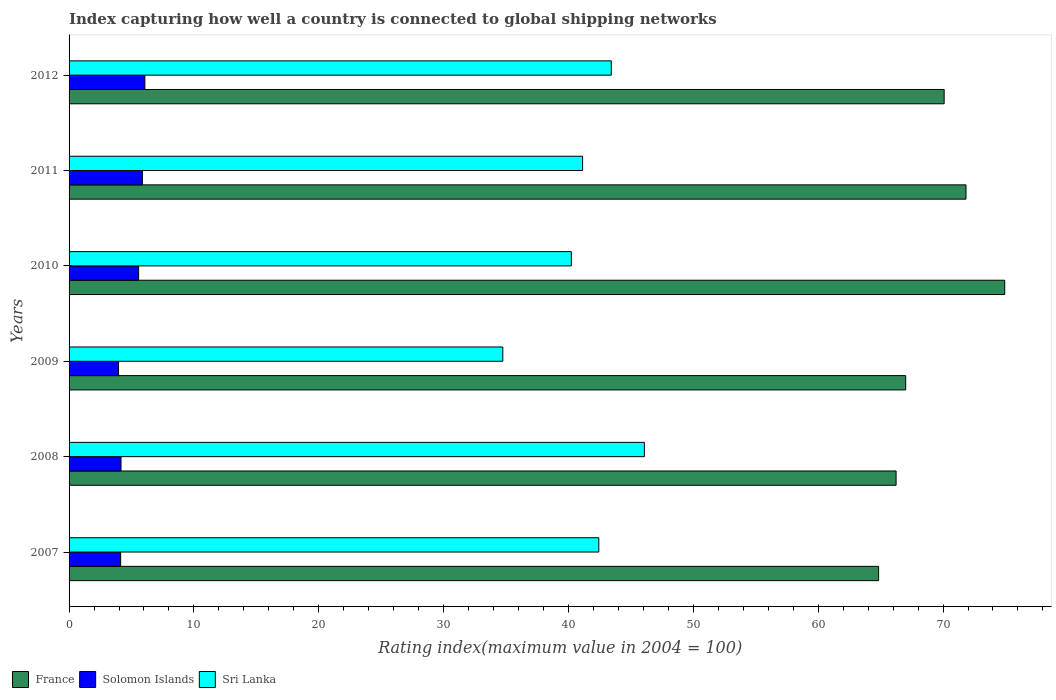Are the number of bars on each tick of the Y-axis equal?
Offer a terse response. Yes. How many bars are there on the 6th tick from the top?
Offer a terse response. 3. In how many cases, is the number of bars for a given year not equal to the number of legend labels?
Make the answer very short. 0. What is the rating index in Solomon Islands in 2008?
Give a very brief answer. 4.16. Across all years, what is the maximum rating index in Sri Lanka?
Ensure brevity in your answer.  46.08. Across all years, what is the minimum rating index in Solomon Islands?
Your answer should be very brief. 3.96. What is the total rating index in France in the graph?
Keep it short and to the point. 414.96. What is the difference between the rating index in Solomon Islands in 2008 and that in 2012?
Make the answer very short. -1.91. What is the difference between the rating index in Solomon Islands in 2011 and the rating index in France in 2007?
Provide a succinct answer. -58.97. What is the average rating index in Solomon Islands per year?
Make the answer very short. 4.96. In the year 2007, what is the difference between the rating index in Solomon Islands and rating index in Sri Lanka?
Keep it short and to the point. -38.3. In how many years, is the rating index in France greater than 8 ?
Offer a very short reply. 6. What is the ratio of the rating index in Sri Lanka in 2008 to that in 2011?
Provide a succinct answer. 1.12. What is the difference between the highest and the second highest rating index in Sri Lanka?
Your answer should be compact. 2.65. What is the difference between the highest and the lowest rating index in Solomon Islands?
Offer a very short reply. 2.11. Is the sum of the rating index in France in 2008 and 2011 greater than the maximum rating index in Solomon Islands across all years?
Offer a very short reply. Yes. What does the 2nd bar from the top in 2011 represents?
Keep it short and to the point. Solomon Islands. What does the 2nd bar from the bottom in 2008 represents?
Offer a very short reply. Solomon Islands. Is it the case that in every year, the sum of the rating index in Solomon Islands and rating index in France is greater than the rating index in Sri Lanka?
Offer a very short reply. Yes. Are all the bars in the graph horizontal?
Offer a terse response. Yes. How many years are there in the graph?
Offer a terse response. 6. What is the difference between two consecutive major ticks on the X-axis?
Your answer should be very brief. 10. Are the values on the major ticks of X-axis written in scientific E-notation?
Make the answer very short. No. Does the graph contain grids?
Offer a very short reply. No. Where does the legend appear in the graph?
Your response must be concise. Bottom left. How many legend labels are there?
Keep it short and to the point. 3. What is the title of the graph?
Provide a succinct answer. Index capturing how well a country is connected to global shipping networks. What is the label or title of the X-axis?
Make the answer very short. Rating index(maximum value in 2004 = 100). What is the label or title of the Y-axis?
Provide a short and direct response. Years. What is the Rating index(maximum value in 2004 = 100) in France in 2007?
Your response must be concise. 64.84. What is the Rating index(maximum value in 2004 = 100) of Solomon Islands in 2007?
Your answer should be compact. 4.13. What is the Rating index(maximum value in 2004 = 100) of Sri Lanka in 2007?
Ensure brevity in your answer.  42.43. What is the Rating index(maximum value in 2004 = 100) of France in 2008?
Your answer should be compact. 66.24. What is the Rating index(maximum value in 2004 = 100) of Solomon Islands in 2008?
Your answer should be compact. 4.16. What is the Rating index(maximum value in 2004 = 100) of Sri Lanka in 2008?
Make the answer very short. 46.08. What is the Rating index(maximum value in 2004 = 100) in France in 2009?
Your answer should be compact. 67.01. What is the Rating index(maximum value in 2004 = 100) in Solomon Islands in 2009?
Offer a terse response. 3.96. What is the Rating index(maximum value in 2004 = 100) of Sri Lanka in 2009?
Your response must be concise. 34.74. What is the Rating index(maximum value in 2004 = 100) in France in 2010?
Give a very brief answer. 74.94. What is the Rating index(maximum value in 2004 = 100) in Solomon Islands in 2010?
Provide a succinct answer. 5.57. What is the Rating index(maximum value in 2004 = 100) in Sri Lanka in 2010?
Provide a succinct answer. 40.23. What is the Rating index(maximum value in 2004 = 100) of France in 2011?
Your answer should be very brief. 71.84. What is the Rating index(maximum value in 2004 = 100) in Solomon Islands in 2011?
Keep it short and to the point. 5.87. What is the Rating index(maximum value in 2004 = 100) of Sri Lanka in 2011?
Keep it short and to the point. 41.13. What is the Rating index(maximum value in 2004 = 100) in France in 2012?
Offer a very short reply. 70.09. What is the Rating index(maximum value in 2004 = 100) of Solomon Islands in 2012?
Make the answer very short. 6.07. What is the Rating index(maximum value in 2004 = 100) of Sri Lanka in 2012?
Give a very brief answer. 43.43. Across all years, what is the maximum Rating index(maximum value in 2004 = 100) of France?
Give a very brief answer. 74.94. Across all years, what is the maximum Rating index(maximum value in 2004 = 100) of Solomon Islands?
Your answer should be very brief. 6.07. Across all years, what is the maximum Rating index(maximum value in 2004 = 100) of Sri Lanka?
Offer a very short reply. 46.08. Across all years, what is the minimum Rating index(maximum value in 2004 = 100) of France?
Offer a very short reply. 64.84. Across all years, what is the minimum Rating index(maximum value in 2004 = 100) in Solomon Islands?
Offer a very short reply. 3.96. Across all years, what is the minimum Rating index(maximum value in 2004 = 100) of Sri Lanka?
Offer a terse response. 34.74. What is the total Rating index(maximum value in 2004 = 100) of France in the graph?
Offer a terse response. 414.96. What is the total Rating index(maximum value in 2004 = 100) in Solomon Islands in the graph?
Offer a terse response. 29.76. What is the total Rating index(maximum value in 2004 = 100) of Sri Lanka in the graph?
Give a very brief answer. 248.04. What is the difference between the Rating index(maximum value in 2004 = 100) of France in 2007 and that in 2008?
Offer a very short reply. -1.4. What is the difference between the Rating index(maximum value in 2004 = 100) of Solomon Islands in 2007 and that in 2008?
Provide a succinct answer. -0.03. What is the difference between the Rating index(maximum value in 2004 = 100) of Sri Lanka in 2007 and that in 2008?
Your response must be concise. -3.65. What is the difference between the Rating index(maximum value in 2004 = 100) of France in 2007 and that in 2009?
Provide a succinct answer. -2.17. What is the difference between the Rating index(maximum value in 2004 = 100) in Solomon Islands in 2007 and that in 2009?
Provide a short and direct response. 0.17. What is the difference between the Rating index(maximum value in 2004 = 100) in Sri Lanka in 2007 and that in 2009?
Your answer should be compact. 7.69. What is the difference between the Rating index(maximum value in 2004 = 100) in Solomon Islands in 2007 and that in 2010?
Provide a short and direct response. -1.44. What is the difference between the Rating index(maximum value in 2004 = 100) in Sri Lanka in 2007 and that in 2010?
Provide a succinct answer. 2.2. What is the difference between the Rating index(maximum value in 2004 = 100) of France in 2007 and that in 2011?
Make the answer very short. -7. What is the difference between the Rating index(maximum value in 2004 = 100) in Solomon Islands in 2007 and that in 2011?
Provide a succinct answer. -1.74. What is the difference between the Rating index(maximum value in 2004 = 100) in France in 2007 and that in 2012?
Provide a succinct answer. -5.25. What is the difference between the Rating index(maximum value in 2004 = 100) in Solomon Islands in 2007 and that in 2012?
Give a very brief answer. -1.94. What is the difference between the Rating index(maximum value in 2004 = 100) in France in 2008 and that in 2009?
Provide a succinct answer. -0.77. What is the difference between the Rating index(maximum value in 2004 = 100) in Solomon Islands in 2008 and that in 2009?
Make the answer very short. 0.2. What is the difference between the Rating index(maximum value in 2004 = 100) in Sri Lanka in 2008 and that in 2009?
Give a very brief answer. 11.34. What is the difference between the Rating index(maximum value in 2004 = 100) in Solomon Islands in 2008 and that in 2010?
Provide a short and direct response. -1.41. What is the difference between the Rating index(maximum value in 2004 = 100) of Sri Lanka in 2008 and that in 2010?
Provide a succinct answer. 5.85. What is the difference between the Rating index(maximum value in 2004 = 100) in France in 2008 and that in 2011?
Your answer should be compact. -5.6. What is the difference between the Rating index(maximum value in 2004 = 100) in Solomon Islands in 2008 and that in 2011?
Make the answer very short. -1.71. What is the difference between the Rating index(maximum value in 2004 = 100) in Sri Lanka in 2008 and that in 2011?
Provide a succinct answer. 4.95. What is the difference between the Rating index(maximum value in 2004 = 100) of France in 2008 and that in 2012?
Keep it short and to the point. -3.85. What is the difference between the Rating index(maximum value in 2004 = 100) in Solomon Islands in 2008 and that in 2012?
Ensure brevity in your answer.  -1.91. What is the difference between the Rating index(maximum value in 2004 = 100) in Sri Lanka in 2008 and that in 2012?
Ensure brevity in your answer.  2.65. What is the difference between the Rating index(maximum value in 2004 = 100) in France in 2009 and that in 2010?
Provide a short and direct response. -7.93. What is the difference between the Rating index(maximum value in 2004 = 100) of Solomon Islands in 2009 and that in 2010?
Keep it short and to the point. -1.61. What is the difference between the Rating index(maximum value in 2004 = 100) in Sri Lanka in 2009 and that in 2010?
Offer a very short reply. -5.49. What is the difference between the Rating index(maximum value in 2004 = 100) in France in 2009 and that in 2011?
Offer a terse response. -4.83. What is the difference between the Rating index(maximum value in 2004 = 100) in Solomon Islands in 2009 and that in 2011?
Make the answer very short. -1.91. What is the difference between the Rating index(maximum value in 2004 = 100) in Sri Lanka in 2009 and that in 2011?
Your answer should be compact. -6.39. What is the difference between the Rating index(maximum value in 2004 = 100) in France in 2009 and that in 2012?
Provide a succinct answer. -3.08. What is the difference between the Rating index(maximum value in 2004 = 100) in Solomon Islands in 2009 and that in 2012?
Your answer should be compact. -2.11. What is the difference between the Rating index(maximum value in 2004 = 100) in Sri Lanka in 2009 and that in 2012?
Offer a terse response. -8.69. What is the difference between the Rating index(maximum value in 2004 = 100) of Solomon Islands in 2010 and that in 2011?
Offer a very short reply. -0.3. What is the difference between the Rating index(maximum value in 2004 = 100) of France in 2010 and that in 2012?
Your response must be concise. 4.85. What is the difference between the Rating index(maximum value in 2004 = 100) of France in 2011 and that in 2012?
Provide a succinct answer. 1.75. What is the difference between the Rating index(maximum value in 2004 = 100) in Solomon Islands in 2011 and that in 2012?
Provide a short and direct response. -0.2. What is the difference between the Rating index(maximum value in 2004 = 100) of France in 2007 and the Rating index(maximum value in 2004 = 100) of Solomon Islands in 2008?
Your answer should be compact. 60.68. What is the difference between the Rating index(maximum value in 2004 = 100) of France in 2007 and the Rating index(maximum value in 2004 = 100) of Sri Lanka in 2008?
Keep it short and to the point. 18.76. What is the difference between the Rating index(maximum value in 2004 = 100) in Solomon Islands in 2007 and the Rating index(maximum value in 2004 = 100) in Sri Lanka in 2008?
Your answer should be very brief. -41.95. What is the difference between the Rating index(maximum value in 2004 = 100) of France in 2007 and the Rating index(maximum value in 2004 = 100) of Solomon Islands in 2009?
Your answer should be very brief. 60.88. What is the difference between the Rating index(maximum value in 2004 = 100) of France in 2007 and the Rating index(maximum value in 2004 = 100) of Sri Lanka in 2009?
Your response must be concise. 30.1. What is the difference between the Rating index(maximum value in 2004 = 100) in Solomon Islands in 2007 and the Rating index(maximum value in 2004 = 100) in Sri Lanka in 2009?
Provide a short and direct response. -30.61. What is the difference between the Rating index(maximum value in 2004 = 100) of France in 2007 and the Rating index(maximum value in 2004 = 100) of Solomon Islands in 2010?
Provide a short and direct response. 59.27. What is the difference between the Rating index(maximum value in 2004 = 100) in France in 2007 and the Rating index(maximum value in 2004 = 100) in Sri Lanka in 2010?
Your response must be concise. 24.61. What is the difference between the Rating index(maximum value in 2004 = 100) in Solomon Islands in 2007 and the Rating index(maximum value in 2004 = 100) in Sri Lanka in 2010?
Give a very brief answer. -36.1. What is the difference between the Rating index(maximum value in 2004 = 100) in France in 2007 and the Rating index(maximum value in 2004 = 100) in Solomon Islands in 2011?
Give a very brief answer. 58.97. What is the difference between the Rating index(maximum value in 2004 = 100) in France in 2007 and the Rating index(maximum value in 2004 = 100) in Sri Lanka in 2011?
Your response must be concise. 23.71. What is the difference between the Rating index(maximum value in 2004 = 100) of Solomon Islands in 2007 and the Rating index(maximum value in 2004 = 100) of Sri Lanka in 2011?
Ensure brevity in your answer.  -37. What is the difference between the Rating index(maximum value in 2004 = 100) of France in 2007 and the Rating index(maximum value in 2004 = 100) of Solomon Islands in 2012?
Offer a very short reply. 58.77. What is the difference between the Rating index(maximum value in 2004 = 100) of France in 2007 and the Rating index(maximum value in 2004 = 100) of Sri Lanka in 2012?
Your answer should be compact. 21.41. What is the difference between the Rating index(maximum value in 2004 = 100) of Solomon Islands in 2007 and the Rating index(maximum value in 2004 = 100) of Sri Lanka in 2012?
Provide a succinct answer. -39.3. What is the difference between the Rating index(maximum value in 2004 = 100) in France in 2008 and the Rating index(maximum value in 2004 = 100) in Solomon Islands in 2009?
Ensure brevity in your answer.  62.28. What is the difference between the Rating index(maximum value in 2004 = 100) of France in 2008 and the Rating index(maximum value in 2004 = 100) of Sri Lanka in 2009?
Ensure brevity in your answer.  31.5. What is the difference between the Rating index(maximum value in 2004 = 100) of Solomon Islands in 2008 and the Rating index(maximum value in 2004 = 100) of Sri Lanka in 2009?
Your response must be concise. -30.58. What is the difference between the Rating index(maximum value in 2004 = 100) in France in 2008 and the Rating index(maximum value in 2004 = 100) in Solomon Islands in 2010?
Keep it short and to the point. 60.67. What is the difference between the Rating index(maximum value in 2004 = 100) in France in 2008 and the Rating index(maximum value in 2004 = 100) in Sri Lanka in 2010?
Provide a succinct answer. 26.01. What is the difference between the Rating index(maximum value in 2004 = 100) in Solomon Islands in 2008 and the Rating index(maximum value in 2004 = 100) in Sri Lanka in 2010?
Provide a short and direct response. -36.07. What is the difference between the Rating index(maximum value in 2004 = 100) in France in 2008 and the Rating index(maximum value in 2004 = 100) in Solomon Islands in 2011?
Provide a succinct answer. 60.37. What is the difference between the Rating index(maximum value in 2004 = 100) in France in 2008 and the Rating index(maximum value in 2004 = 100) in Sri Lanka in 2011?
Offer a very short reply. 25.11. What is the difference between the Rating index(maximum value in 2004 = 100) of Solomon Islands in 2008 and the Rating index(maximum value in 2004 = 100) of Sri Lanka in 2011?
Provide a short and direct response. -36.97. What is the difference between the Rating index(maximum value in 2004 = 100) in France in 2008 and the Rating index(maximum value in 2004 = 100) in Solomon Islands in 2012?
Your answer should be very brief. 60.17. What is the difference between the Rating index(maximum value in 2004 = 100) of France in 2008 and the Rating index(maximum value in 2004 = 100) of Sri Lanka in 2012?
Keep it short and to the point. 22.81. What is the difference between the Rating index(maximum value in 2004 = 100) of Solomon Islands in 2008 and the Rating index(maximum value in 2004 = 100) of Sri Lanka in 2012?
Ensure brevity in your answer.  -39.27. What is the difference between the Rating index(maximum value in 2004 = 100) of France in 2009 and the Rating index(maximum value in 2004 = 100) of Solomon Islands in 2010?
Provide a succinct answer. 61.44. What is the difference between the Rating index(maximum value in 2004 = 100) in France in 2009 and the Rating index(maximum value in 2004 = 100) in Sri Lanka in 2010?
Your answer should be very brief. 26.78. What is the difference between the Rating index(maximum value in 2004 = 100) of Solomon Islands in 2009 and the Rating index(maximum value in 2004 = 100) of Sri Lanka in 2010?
Provide a succinct answer. -36.27. What is the difference between the Rating index(maximum value in 2004 = 100) of France in 2009 and the Rating index(maximum value in 2004 = 100) of Solomon Islands in 2011?
Your answer should be compact. 61.14. What is the difference between the Rating index(maximum value in 2004 = 100) in France in 2009 and the Rating index(maximum value in 2004 = 100) in Sri Lanka in 2011?
Make the answer very short. 25.88. What is the difference between the Rating index(maximum value in 2004 = 100) in Solomon Islands in 2009 and the Rating index(maximum value in 2004 = 100) in Sri Lanka in 2011?
Your response must be concise. -37.17. What is the difference between the Rating index(maximum value in 2004 = 100) in France in 2009 and the Rating index(maximum value in 2004 = 100) in Solomon Islands in 2012?
Offer a very short reply. 60.94. What is the difference between the Rating index(maximum value in 2004 = 100) of France in 2009 and the Rating index(maximum value in 2004 = 100) of Sri Lanka in 2012?
Offer a very short reply. 23.58. What is the difference between the Rating index(maximum value in 2004 = 100) of Solomon Islands in 2009 and the Rating index(maximum value in 2004 = 100) of Sri Lanka in 2012?
Give a very brief answer. -39.47. What is the difference between the Rating index(maximum value in 2004 = 100) in France in 2010 and the Rating index(maximum value in 2004 = 100) in Solomon Islands in 2011?
Make the answer very short. 69.07. What is the difference between the Rating index(maximum value in 2004 = 100) of France in 2010 and the Rating index(maximum value in 2004 = 100) of Sri Lanka in 2011?
Your response must be concise. 33.81. What is the difference between the Rating index(maximum value in 2004 = 100) in Solomon Islands in 2010 and the Rating index(maximum value in 2004 = 100) in Sri Lanka in 2011?
Make the answer very short. -35.56. What is the difference between the Rating index(maximum value in 2004 = 100) in France in 2010 and the Rating index(maximum value in 2004 = 100) in Solomon Islands in 2012?
Your answer should be very brief. 68.87. What is the difference between the Rating index(maximum value in 2004 = 100) in France in 2010 and the Rating index(maximum value in 2004 = 100) in Sri Lanka in 2012?
Your answer should be very brief. 31.51. What is the difference between the Rating index(maximum value in 2004 = 100) of Solomon Islands in 2010 and the Rating index(maximum value in 2004 = 100) of Sri Lanka in 2012?
Give a very brief answer. -37.86. What is the difference between the Rating index(maximum value in 2004 = 100) in France in 2011 and the Rating index(maximum value in 2004 = 100) in Solomon Islands in 2012?
Your response must be concise. 65.77. What is the difference between the Rating index(maximum value in 2004 = 100) in France in 2011 and the Rating index(maximum value in 2004 = 100) in Sri Lanka in 2012?
Offer a terse response. 28.41. What is the difference between the Rating index(maximum value in 2004 = 100) of Solomon Islands in 2011 and the Rating index(maximum value in 2004 = 100) of Sri Lanka in 2012?
Offer a terse response. -37.56. What is the average Rating index(maximum value in 2004 = 100) of France per year?
Offer a very short reply. 69.16. What is the average Rating index(maximum value in 2004 = 100) of Solomon Islands per year?
Offer a very short reply. 4.96. What is the average Rating index(maximum value in 2004 = 100) of Sri Lanka per year?
Keep it short and to the point. 41.34. In the year 2007, what is the difference between the Rating index(maximum value in 2004 = 100) in France and Rating index(maximum value in 2004 = 100) in Solomon Islands?
Give a very brief answer. 60.71. In the year 2007, what is the difference between the Rating index(maximum value in 2004 = 100) of France and Rating index(maximum value in 2004 = 100) of Sri Lanka?
Provide a short and direct response. 22.41. In the year 2007, what is the difference between the Rating index(maximum value in 2004 = 100) of Solomon Islands and Rating index(maximum value in 2004 = 100) of Sri Lanka?
Ensure brevity in your answer.  -38.3. In the year 2008, what is the difference between the Rating index(maximum value in 2004 = 100) in France and Rating index(maximum value in 2004 = 100) in Solomon Islands?
Offer a very short reply. 62.08. In the year 2008, what is the difference between the Rating index(maximum value in 2004 = 100) in France and Rating index(maximum value in 2004 = 100) in Sri Lanka?
Keep it short and to the point. 20.16. In the year 2008, what is the difference between the Rating index(maximum value in 2004 = 100) of Solomon Islands and Rating index(maximum value in 2004 = 100) of Sri Lanka?
Keep it short and to the point. -41.92. In the year 2009, what is the difference between the Rating index(maximum value in 2004 = 100) in France and Rating index(maximum value in 2004 = 100) in Solomon Islands?
Provide a succinct answer. 63.05. In the year 2009, what is the difference between the Rating index(maximum value in 2004 = 100) of France and Rating index(maximum value in 2004 = 100) of Sri Lanka?
Provide a succinct answer. 32.27. In the year 2009, what is the difference between the Rating index(maximum value in 2004 = 100) of Solomon Islands and Rating index(maximum value in 2004 = 100) of Sri Lanka?
Ensure brevity in your answer.  -30.78. In the year 2010, what is the difference between the Rating index(maximum value in 2004 = 100) of France and Rating index(maximum value in 2004 = 100) of Solomon Islands?
Keep it short and to the point. 69.37. In the year 2010, what is the difference between the Rating index(maximum value in 2004 = 100) of France and Rating index(maximum value in 2004 = 100) of Sri Lanka?
Give a very brief answer. 34.71. In the year 2010, what is the difference between the Rating index(maximum value in 2004 = 100) in Solomon Islands and Rating index(maximum value in 2004 = 100) in Sri Lanka?
Offer a very short reply. -34.66. In the year 2011, what is the difference between the Rating index(maximum value in 2004 = 100) of France and Rating index(maximum value in 2004 = 100) of Solomon Islands?
Your answer should be very brief. 65.97. In the year 2011, what is the difference between the Rating index(maximum value in 2004 = 100) of France and Rating index(maximum value in 2004 = 100) of Sri Lanka?
Your answer should be very brief. 30.71. In the year 2011, what is the difference between the Rating index(maximum value in 2004 = 100) in Solomon Islands and Rating index(maximum value in 2004 = 100) in Sri Lanka?
Make the answer very short. -35.26. In the year 2012, what is the difference between the Rating index(maximum value in 2004 = 100) of France and Rating index(maximum value in 2004 = 100) of Solomon Islands?
Your response must be concise. 64.02. In the year 2012, what is the difference between the Rating index(maximum value in 2004 = 100) of France and Rating index(maximum value in 2004 = 100) of Sri Lanka?
Keep it short and to the point. 26.66. In the year 2012, what is the difference between the Rating index(maximum value in 2004 = 100) in Solomon Islands and Rating index(maximum value in 2004 = 100) in Sri Lanka?
Your response must be concise. -37.36. What is the ratio of the Rating index(maximum value in 2004 = 100) of France in 2007 to that in 2008?
Your answer should be compact. 0.98. What is the ratio of the Rating index(maximum value in 2004 = 100) of Solomon Islands in 2007 to that in 2008?
Your response must be concise. 0.99. What is the ratio of the Rating index(maximum value in 2004 = 100) of Sri Lanka in 2007 to that in 2008?
Ensure brevity in your answer.  0.92. What is the ratio of the Rating index(maximum value in 2004 = 100) of France in 2007 to that in 2009?
Provide a succinct answer. 0.97. What is the ratio of the Rating index(maximum value in 2004 = 100) in Solomon Islands in 2007 to that in 2009?
Your response must be concise. 1.04. What is the ratio of the Rating index(maximum value in 2004 = 100) in Sri Lanka in 2007 to that in 2009?
Keep it short and to the point. 1.22. What is the ratio of the Rating index(maximum value in 2004 = 100) of France in 2007 to that in 2010?
Offer a very short reply. 0.87. What is the ratio of the Rating index(maximum value in 2004 = 100) of Solomon Islands in 2007 to that in 2010?
Ensure brevity in your answer.  0.74. What is the ratio of the Rating index(maximum value in 2004 = 100) in Sri Lanka in 2007 to that in 2010?
Your answer should be compact. 1.05. What is the ratio of the Rating index(maximum value in 2004 = 100) in France in 2007 to that in 2011?
Give a very brief answer. 0.9. What is the ratio of the Rating index(maximum value in 2004 = 100) of Solomon Islands in 2007 to that in 2011?
Make the answer very short. 0.7. What is the ratio of the Rating index(maximum value in 2004 = 100) of Sri Lanka in 2007 to that in 2011?
Keep it short and to the point. 1.03. What is the ratio of the Rating index(maximum value in 2004 = 100) of France in 2007 to that in 2012?
Your response must be concise. 0.93. What is the ratio of the Rating index(maximum value in 2004 = 100) of Solomon Islands in 2007 to that in 2012?
Your response must be concise. 0.68. What is the ratio of the Rating index(maximum value in 2004 = 100) of Sri Lanka in 2007 to that in 2012?
Make the answer very short. 0.98. What is the ratio of the Rating index(maximum value in 2004 = 100) in Solomon Islands in 2008 to that in 2009?
Your answer should be compact. 1.05. What is the ratio of the Rating index(maximum value in 2004 = 100) in Sri Lanka in 2008 to that in 2009?
Provide a succinct answer. 1.33. What is the ratio of the Rating index(maximum value in 2004 = 100) of France in 2008 to that in 2010?
Your answer should be very brief. 0.88. What is the ratio of the Rating index(maximum value in 2004 = 100) in Solomon Islands in 2008 to that in 2010?
Make the answer very short. 0.75. What is the ratio of the Rating index(maximum value in 2004 = 100) of Sri Lanka in 2008 to that in 2010?
Your answer should be very brief. 1.15. What is the ratio of the Rating index(maximum value in 2004 = 100) of France in 2008 to that in 2011?
Your response must be concise. 0.92. What is the ratio of the Rating index(maximum value in 2004 = 100) in Solomon Islands in 2008 to that in 2011?
Make the answer very short. 0.71. What is the ratio of the Rating index(maximum value in 2004 = 100) of Sri Lanka in 2008 to that in 2011?
Offer a terse response. 1.12. What is the ratio of the Rating index(maximum value in 2004 = 100) of France in 2008 to that in 2012?
Provide a succinct answer. 0.95. What is the ratio of the Rating index(maximum value in 2004 = 100) of Solomon Islands in 2008 to that in 2012?
Make the answer very short. 0.69. What is the ratio of the Rating index(maximum value in 2004 = 100) of Sri Lanka in 2008 to that in 2012?
Offer a very short reply. 1.06. What is the ratio of the Rating index(maximum value in 2004 = 100) of France in 2009 to that in 2010?
Keep it short and to the point. 0.89. What is the ratio of the Rating index(maximum value in 2004 = 100) in Solomon Islands in 2009 to that in 2010?
Your answer should be very brief. 0.71. What is the ratio of the Rating index(maximum value in 2004 = 100) of Sri Lanka in 2009 to that in 2010?
Give a very brief answer. 0.86. What is the ratio of the Rating index(maximum value in 2004 = 100) of France in 2009 to that in 2011?
Give a very brief answer. 0.93. What is the ratio of the Rating index(maximum value in 2004 = 100) in Solomon Islands in 2009 to that in 2011?
Your answer should be very brief. 0.67. What is the ratio of the Rating index(maximum value in 2004 = 100) of Sri Lanka in 2009 to that in 2011?
Ensure brevity in your answer.  0.84. What is the ratio of the Rating index(maximum value in 2004 = 100) of France in 2009 to that in 2012?
Your answer should be very brief. 0.96. What is the ratio of the Rating index(maximum value in 2004 = 100) in Solomon Islands in 2009 to that in 2012?
Your answer should be compact. 0.65. What is the ratio of the Rating index(maximum value in 2004 = 100) in Sri Lanka in 2009 to that in 2012?
Provide a short and direct response. 0.8. What is the ratio of the Rating index(maximum value in 2004 = 100) in France in 2010 to that in 2011?
Ensure brevity in your answer.  1.04. What is the ratio of the Rating index(maximum value in 2004 = 100) in Solomon Islands in 2010 to that in 2011?
Your answer should be very brief. 0.95. What is the ratio of the Rating index(maximum value in 2004 = 100) of Sri Lanka in 2010 to that in 2011?
Give a very brief answer. 0.98. What is the ratio of the Rating index(maximum value in 2004 = 100) in France in 2010 to that in 2012?
Provide a succinct answer. 1.07. What is the ratio of the Rating index(maximum value in 2004 = 100) in Solomon Islands in 2010 to that in 2012?
Give a very brief answer. 0.92. What is the ratio of the Rating index(maximum value in 2004 = 100) of Sri Lanka in 2010 to that in 2012?
Your response must be concise. 0.93. What is the ratio of the Rating index(maximum value in 2004 = 100) of Solomon Islands in 2011 to that in 2012?
Offer a very short reply. 0.97. What is the ratio of the Rating index(maximum value in 2004 = 100) of Sri Lanka in 2011 to that in 2012?
Your answer should be compact. 0.95. What is the difference between the highest and the second highest Rating index(maximum value in 2004 = 100) in France?
Provide a succinct answer. 3.1. What is the difference between the highest and the second highest Rating index(maximum value in 2004 = 100) of Solomon Islands?
Your answer should be very brief. 0.2. What is the difference between the highest and the second highest Rating index(maximum value in 2004 = 100) of Sri Lanka?
Your answer should be compact. 2.65. What is the difference between the highest and the lowest Rating index(maximum value in 2004 = 100) in France?
Provide a succinct answer. 10.1. What is the difference between the highest and the lowest Rating index(maximum value in 2004 = 100) in Solomon Islands?
Offer a very short reply. 2.11. What is the difference between the highest and the lowest Rating index(maximum value in 2004 = 100) in Sri Lanka?
Your answer should be very brief. 11.34. 